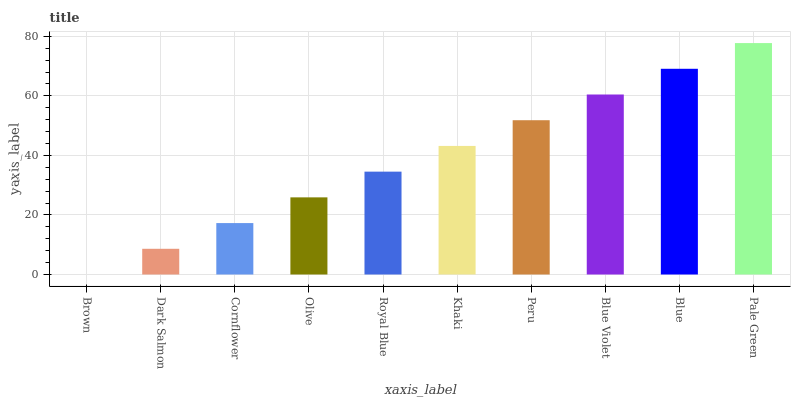Is Brown the minimum?
Answer yes or no. Yes. Is Pale Green the maximum?
Answer yes or no. Yes. Is Dark Salmon the minimum?
Answer yes or no. No. Is Dark Salmon the maximum?
Answer yes or no. No. Is Dark Salmon greater than Brown?
Answer yes or no. Yes. Is Brown less than Dark Salmon?
Answer yes or no. Yes. Is Brown greater than Dark Salmon?
Answer yes or no. No. Is Dark Salmon less than Brown?
Answer yes or no. No. Is Khaki the high median?
Answer yes or no. Yes. Is Royal Blue the low median?
Answer yes or no. Yes. Is Olive the high median?
Answer yes or no. No. Is Blue the low median?
Answer yes or no. No. 